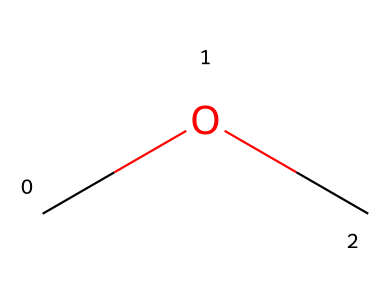What is the name of this chemical? The SMILES representation "COC" corresponds to dimethyl ether, which is an ether compound formed from two methyl groups bonded to an oxygen atom.
Answer: dimethyl ether How many carbon atoms are in this compound? The structure "COC" indicates there are two carbon atoms (C) present in the molecule, one from each methyl group.
Answer: 2 What functional group is present in dimethyl ether? The presence of the oxygen atom (O) bridging the two carbon atoms indicates that this compound contains an ether functional group.
Answer: ether How many hydrogen atoms are present in dimethyl ether? Each methyl group (CH3) contributes three hydrogen atoms. With two methyl groups, the total is 6 hydrogen atoms (3 from each).
Answer: 6 What is the bond type between carbon and oxygen in this compound? The bond between the carbon (C) atoms and the oxygen (O) atom in dimethyl ether is a single covalent bond, as indicated by the absence of any double or triple bond notation in the SMILES.
Answer: single Is dimethyl ether polar or non-polar? Dimethyl ether has a slight polarity due to the oxygen atom creating a dipole moment, despite having a symmetrical structure overall.
Answer: polar 